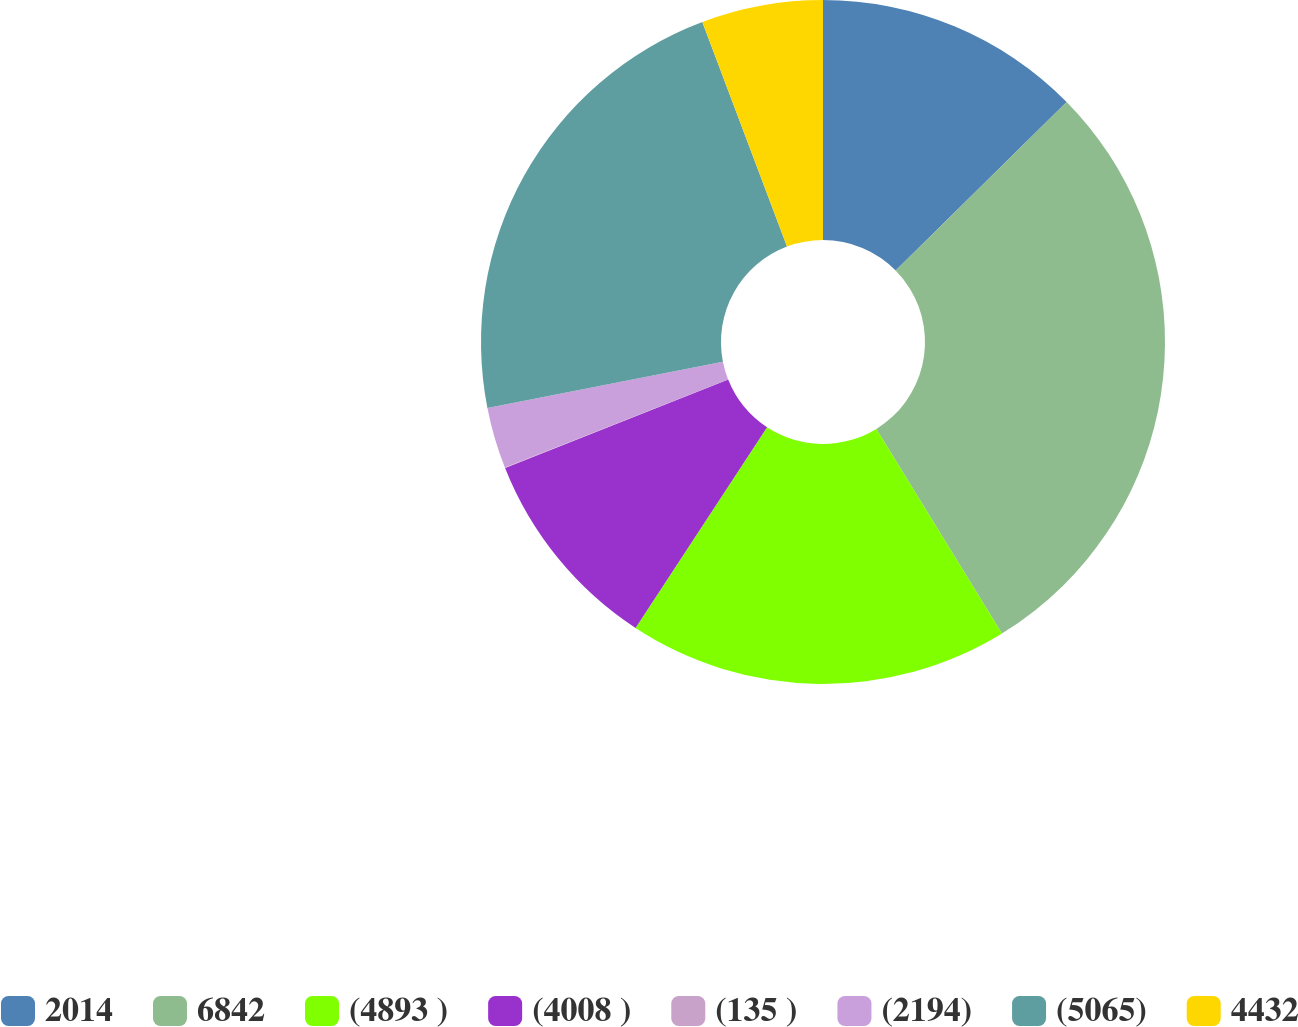<chart> <loc_0><loc_0><loc_500><loc_500><pie_chart><fcel>2014<fcel>6842<fcel>(4893 )<fcel>(4008 )<fcel>(135 )<fcel>(2194)<fcel>(5065)<fcel>4432<nl><fcel>12.62%<fcel>28.62%<fcel>18.0%<fcel>9.76%<fcel>0.03%<fcel>2.89%<fcel>22.35%<fcel>5.74%<nl></chart> 